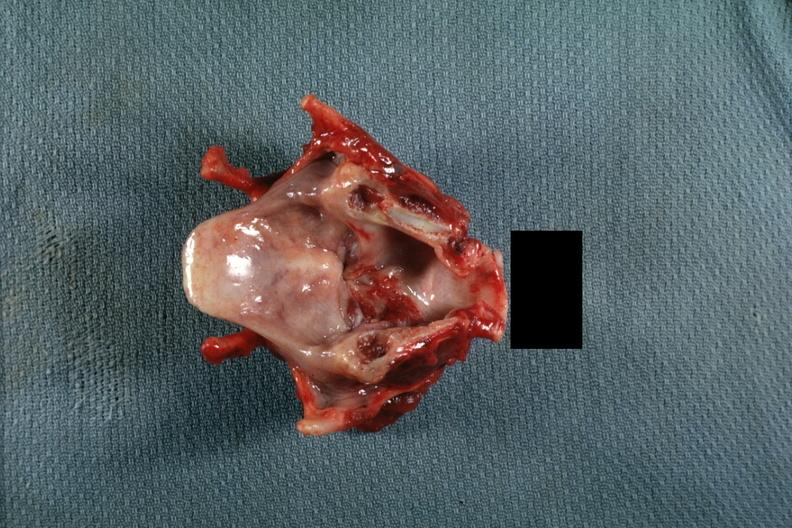s larynx present?
Answer the question using a single word or phrase. Yes 